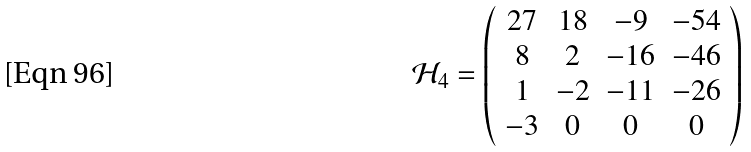Convert formula to latex. <formula><loc_0><loc_0><loc_500><loc_500>\mathcal { H } _ { 4 } = \left ( \begin{array} { c c c c c c c } 2 7 & 1 8 & - 9 & - 5 4 \\ 8 & 2 & - 1 6 & - 4 6 \\ 1 & - 2 & - 1 1 & - 2 6 \\ - 3 & 0 & 0 & 0 \\ \end{array} \right )</formula> 